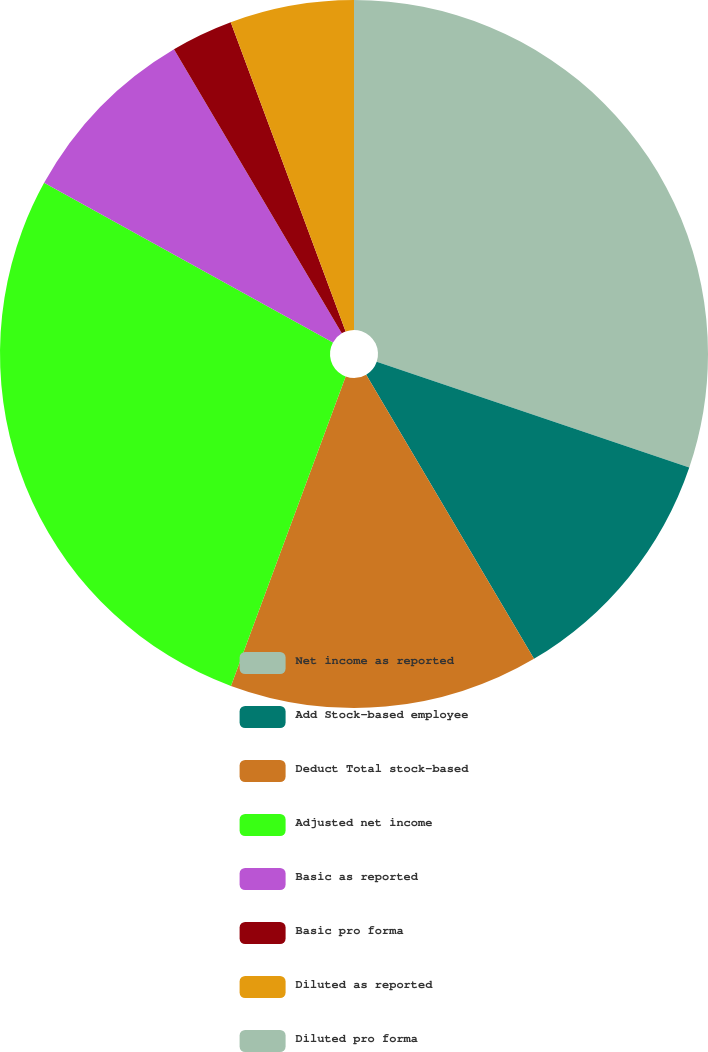<chart> <loc_0><loc_0><loc_500><loc_500><pie_chart><fcel>Net income as reported<fcel>Add Stock-based employee<fcel>Deduct Total stock-based<fcel>Adjusted net income<fcel>Basic as reported<fcel>Basic pro forma<fcel>Diluted as reported<fcel>Diluted pro forma<nl><fcel>30.2%<fcel>11.31%<fcel>14.14%<fcel>27.38%<fcel>8.48%<fcel>2.83%<fcel>5.66%<fcel>0.0%<nl></chart> 